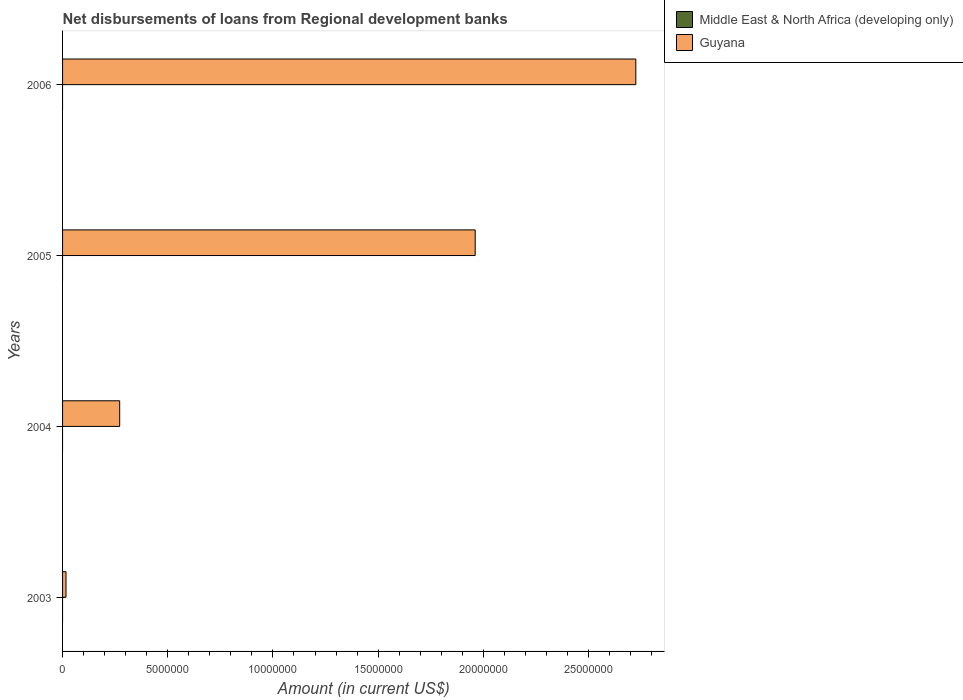How many different coloured bars are there?
Your response must be concise. 1. Are the number of bars on each tick of the Y-axis equal?
Give a very brief answer. Yes. How many bars are there on the 2nd tick from the top?
Give a very brief answer. 1. How many bars are there on the 1st tick from the bottom?
Give a very brief answer. 1. What is the amount of disbursements of loans from regional development banks in Middle East & North Africa (developing only) in 2003?
Your response must be concise. 0. Across all years, what is the maximum amount of disbursements of loans from regional development banks in Guyana?
Provide a succinct answer. 2.72e+07. What is the total amount of disbursements of loans from regional development banks in Middle East & North Africa (developing only) in the graph?
Your answer should be very brief. 0. What is the difference between the amount of disbursements of loans from regional development banks in Guyana in 2004 and that in 2006?
Ensure brevity in your answer.  -2.45e+07. What is the difference between the amount of disbursements of loans from regional development banks in Guyana in 2005 and the amount of disbursements of loans from regional development banks in Middle East & North Africa (developing only) in 2003?
Keep it short and to the point. 1.96e+07. What is the average amount of disbursements of loans from regional development banks in Middle East & North Africa (developing only) per year?
Offer a very short reply. 0. In how many years, is the amount of disbursements of loans from regional development banks in Middle East & North Africa (developing only) greater than 3000000 US$?
Ensure brevity in your answer.  0. What is the difference between the highest and the second highest amount of disbursements of loans from regional development banks in Guyana?
Your response must be concise. 7.64e+06. What is the difference between the highest and the lowest amount of disbursements of loans from regional development banks in Guyana?
Provide a short and direct response. 2.71e+07. In how many years, is the amount of disbursements of loans from regional development banks in Middle East & North Africa (developing only) greater than the average amount of disbursements of loans from regional development banks in Middle East & North Africa (developing only) taken over all years?
Keep it short and to the point. 0. Is the sum of the amount of disbursements of loans from regional development banks in Guyana in 2003 and 2004 greater than the maximum amount of disbursements of loans from regional development banks in Middle East & North Africa (developing only) across all years?
Your answer should be compact. Yes. How many bars are there?
Offer a terse response. 4. Are all the bars in the graph horizontal?
Make the answer very short. Yes. How many years are there in the graph?
Offer a terse response. 4. Does the graph contain any zero values?
Give a very brief answer. Yes. Where does the legend appear in the graph?
Provide a succinct answer. Top right. How many legend labels are there?
Provide a succinct answer. 2. What is the title of the graph?
Your answer should be compact. Net disbursements of loans from Regional development banks. What is the label or title of the X-axis?
Offer a terse response. Amount (in current US$). What is the label or title of the Y-axis?
Give a very brief answer. Years. What is the Amount (in current US$) in Middle East & North Africa (developing only) in 2003?
Offer a very short reply. 0. What is the Amount (in current US$) of Guyana in 2003?
Provide a short and direct response. 1.64e+05. What is the Amount (in current US$) of Middle East & North Africa (developing only) in 2004?
Provide a succinct answer. 0. What is the Amount (in current US$) in Guyana in 2004?
Your answer should be compact. 2.72e+06. What is the Amount (in current US$) of Guyana in 2005?
Ensure brevity in your answer.  1.96e+07. What is the Amount (in current US$) of Middle East & North Africa (developing only) in 2006?
Your answer should be very brief. 0. What is the Amount (in current US$) in Guyana in 2006?
Your answer should be compact. 2.72e+07. Across all years, what is the maximum Amount (in current US$) in Guyana?
Ensure brevity in your answer.  2.72e+07. Across all years, what is the minimum Amount (in current US$) of Guyana?
Your answer should be very brief. 1.64e+05. What is the total Amount (in current US$) in Guyana in the graph?
Ensure brevity in your answer.  4.97e+07. What is the difference between the Amount (in current US$) in Guyana in 2003 and that in 2004?
Offer a terse response. -2.55e+06. What is the difference between the Amount (in current US$) in Guyana in 2003 and that in 2005?
Your answer should be compact. -1.95e+07. What is the difference between the Amount (in current US$) in Guyana in 2003 and that in 2006?
Provide a succinct answer. -2.71e+07. What is the difference between the Amount (in current US$) in Guyana in 2004 and that in 2005?
Your answer should be very brief. -1.69e+07. What is the difference between the Amount (in current US$) in Guyana in 2004 and that in 2006?
Provide a succinct answer. -2.45e+07. What is the difference between the Amount (in current US$) of Guyana in 2005 and that in 2006?
Provide a succinct answer. -7.64e+06. What is the average Amount (in current US$) in Middle East & North Africa (developing only) per year?
Your answer should be very brief. 0. What is the average Amount (in current US$) in Guyana per year?
Make the answer very short. 1.24e+07. What is the ratio of the Amount (in current US$) of Guyana in 2003 to that in 2004?
Offer a terse response. 0.06. What is the ratio of the Amount (in current US$) in Guyana in 2003 to that in 2005?
Your answer should be very brief. 0.01. What is the ratio of the Amount (in current US$) of Guyana in 2003 to that in 2006?
Keep it short and to the point. 0.01. What is the ratio of the Amount (in current US$) of Guyana in 2004 to that in 2005?
Your answer should be compact. 0.14. What is the ratio of the Amount (in current US$) of Guyana in 2004 to that in 2006?
Offer a terse response. 0.1. What is the ratio of the Amount (in current US$) of Guyana in 2005 to that in 2006?
Your answer should be very brief. 0.72. What is the difference between the highest and the second highest Amount (in current US$) of Guyana?
Offer a very short reply. 7.64e+06. What is the difference between the highest and the lowest Amount (in current US$) in Guyana?
Give a very brief answer. 2.71e+07. 